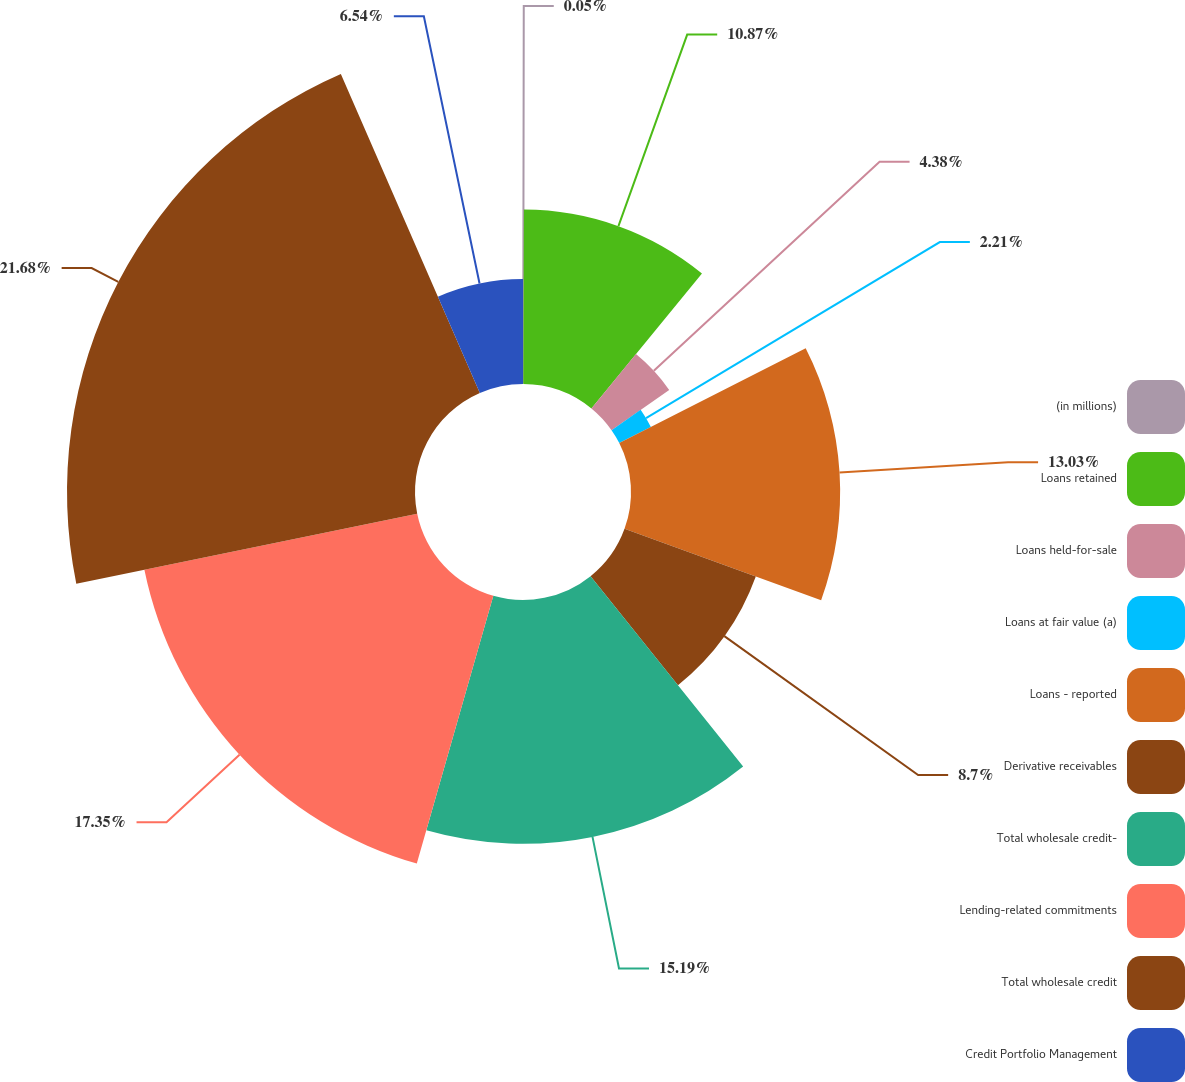Convert chart. <chart><loc_0><loc_0><loc_500><loc_500><pie_chart><fcel>(in millions)<fcel>Loans retained<fcel>Loans held-for-sale<fcel>Loans at fair value (a)<fcel>Loans - reported<fcel>Derivative receivables<fcel>Total wholesale credit-<fcel>Lending-related commitments<fcel>Total wholesale credit<fcel>Credit Portfolio Management<nl><fcel>0.05%<fcel>10.87%<fcel>4.38%<fcel>2.21%<fcel>13.03%<fcel>8.7%<fcel>15.19%<fcel>17.35%<fcel>21.68%<fcel>6.54%<nl></chart> 